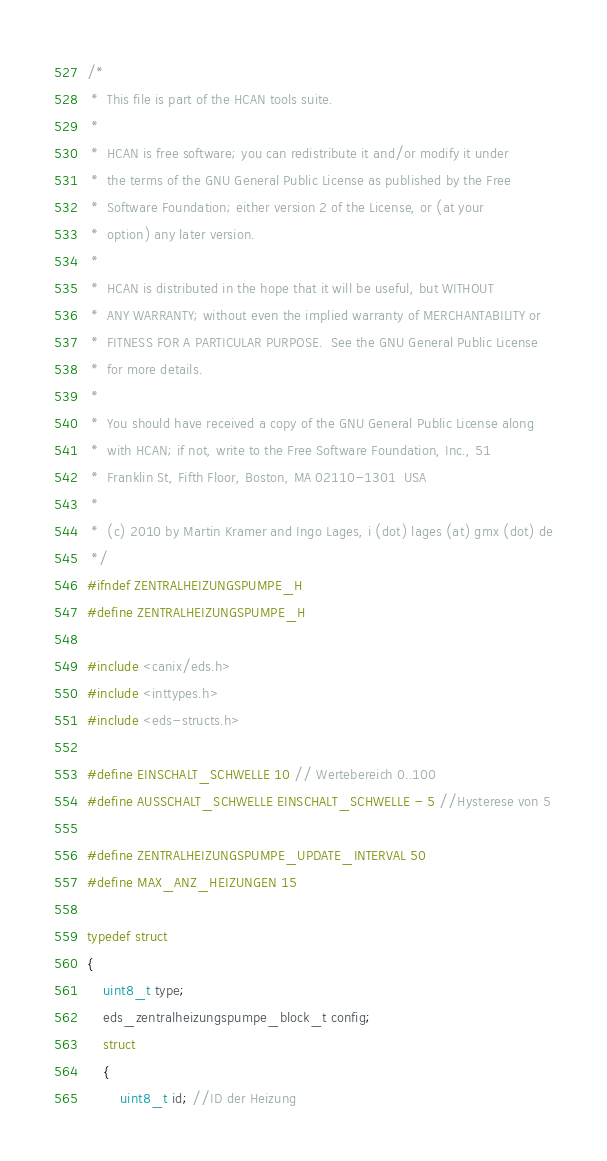Convert code to text. <code><loc_0><loc_0><loc_500><loc_500><_C_>/*
 *  This file is part of the HCAN tools suite.
 *
 *  HCAN is free software; you can redistribute it and/or modify it under
 *  the terms of the GNU General Public License as published by the Free
 *  Software Foundation; either version 2 of the License, or (at your
 *  option) any later version.
 *
 *  HCAN is distributed in the hope that it will be useful, but WITHOUT
 *  ANY WARRANTY; without even the implied warranty of MERCHANTABILITY or
 *  FITNESS FOR A PARTICULAR PURPOSE.  See the GNU General Public License
 *  for more details.
 *
 *  You should have received a copy of the GNU General Public License along
 *  with HCAN; if not, write to the Free Software Foundation, Inc., 51
 *  Franklin St, Fifth Floor, Boston, MA 02110-1301  USA
 *
 *  (c) 2010 by Martin Kramer and Ingo Lages, i (dot) lages (at) gmx (dot) de
 */
#ifndef ZENTRALHEIZUNGSPUMPE_H
#define ZENTRALHEIZUNGSPUMPE_H

#include <canix/eds.h>
#include <inttypes.h>
#include <eds-structs.h>

#define EINSCHALT_SCHWELLE 10 // Wertebereich 0..100
#define AUSSCHALT_SCHWELLE EINSCHALT_SCHWELLE - 5 //Hysterese von 5

#define ZENTRALHEIZUNGSPUMPE_UPDATE_INTERVAL 50
#define MAX_ANZ_HEIZUNGEN 15

typedef struct
{
	uint8_t type;
	eds_zentralheizungspumpe_block_t config;
	struct
	{
		uint8_t id; //ID der Heizung</code> 